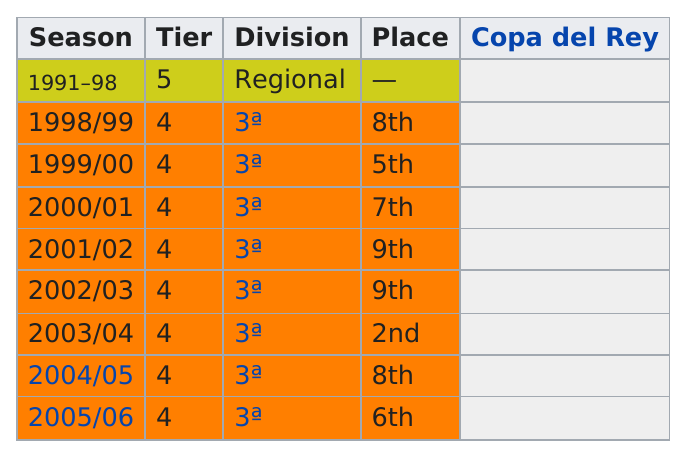Highlight a few significant elements in this photo. Our team finished in the same position in the 2001/2002 season as we did in the 2002/2003 season. The team finished eighth in the 1998/1999 season and also finished eighth in the 2004/2005 season. In the 2004/2005 season, Manchester United finished in the same place as they did in the 1998-1999 season. In 1998 and 2004, they were in the 8th place. There are 8 seasons in Tier 4. 